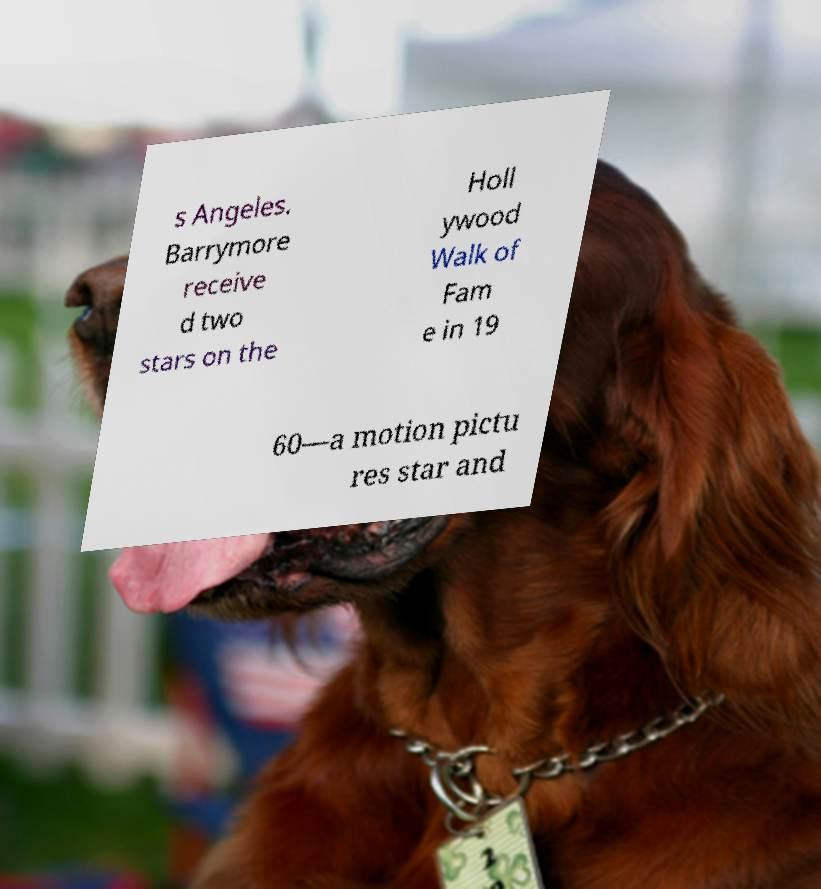For documentation purposes, I need the text within this image transcribed. Could you provide that? s Angeles. Barrymore receive d two stars on the Holl ywood Walk of Fam e in 19 60—a motion pictu res star and 